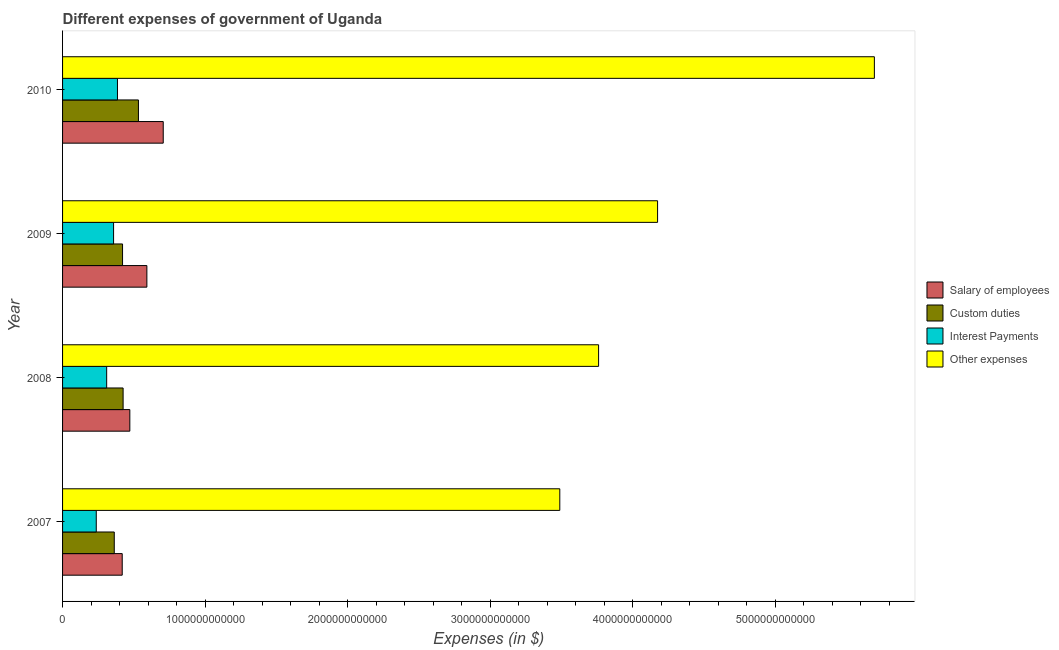How many different coloured bars are there?
Your answer should be very brief. 4. Are the number of bars on each tick of the Y-axis equal?
Your answer should be very brief. Yes. How many bars are there on the 1st tick from the top?
Provide a short and direct response. 4. What is the amount spent on salary of employees in 2010?
Ensure brevity in your answer.  7.06e+11. Across all years, what is the maximum amount spent on custom duties?
Give a very brief answer. 5.32e+11. Across all years, what is the minimum amount spent on interest payments?
Offer a very short reply. 2.36e+11. In which year was the amount spent on other expenses maximum?
Ensure brevity in your answer.  2010. What is the total amount spent on interest payments in the graph?
Ensure brevity in your answer.  1.29e+12. What is the difference between the amount spent on other expenses in 2007 and that in 2010?
Provide a short and direct response. -2.21e+12. What is the difference between the amount spent on custom duties in 2010 and the amount spent on interest payments in 2008?
Your answer should be very brief. 2.23e+11. What is the average amount spent on interest payments per year?
Give a very brief answer. 3.22e+11. In the year 2007, what is the difference between the amount spent on other expenses and amount spent on salary of employees?
Your answer should be compact. 3.07e+12. In how many years, is the amount spent on custom duties greater than 2000000000000 $?
Your answer should be compact. 0. What is the ratio of the amount spent on custom duties in 2007 to that in 2008?
Your answer should be very brief. 0.85. What is the difference between the highest and the second highest amount spent on interest payments?
Your answer should be very brief. 2.73e+1. What is the difference between the highest and the lowest amount spent on custom duties?
Your answer should be very brief. 1.70e+11. What does the 3rd bar from the top in 2010 represents?
Give a very brief answer. Custom duties. What does the 2nd bar from the bottom in 2008 represents?
Your response must be concise. Custom duties. Is it the case that in every year, the sum of the amount spent on salary of employees and amount spent on custom duties is greater than the amount spent on interest payments?
Ensure brevity in your answer.  Yes. How many years are there in the graph?
Your response must be concise. 4. What is the difference between two consecutive major ticks on the X-axis?
Keep it short and to the point. 1.00e+12. Are the values on the major ticks of X-axis written in scientific E-notation?
Provide a short and direct response. No. Does the graph contain any zero values?
Offer a very short reply. No. Does the graph contain grids?
Your answer should be very brief. No. Where does the legend appear in the graph?
Give a very brief answer. Center right. How many legend labels are there?
Offer a terse response. 4. What is the title of the graph?
Keep it short and to the point. Different expenses of government of Uganda. What is the label or title of the X-axis?
Provide a short and direct response. Expenses (in $). What is the Expenses (in $) in Salary of employees in 2007?
Your response must be concise. 4.18e+11. What is the Expenses (in $) of Custom duties in 2007?
Your answer should be compact. 3.63e+11. What is the Expenses (in $) in Interest Payments in 2007?
Provide a short and direct response. 2.36e+11. What is the Expenses (in $) of Other expenses in 2007?
Your response must be concise. 3.49e+12. What is the Expenses (in $) in Salary of employees in 2008?
Give a very brief answer. 4.72e+11. What is the Expenses (in $) of Custom duties in 2008?
Keep it short and to the point. 4.25e+11. What is the Expenses (in $) in Interest Payments in 2008?
Provide a succinct answer. 3.09e+11. What is the Expenses (in $) in Other expenses in 2008?
Provide a succinct answer. 3.76e+12. What is the Expenses (in $) of Salary of employees in 2009?
Provide a succinct answer. 5.91e+11. What is the Expenses (in $) of Custom duties in 2009?
Give a very brief answer. 4.21e+11. What is the Expenses (in $) of Interest Payments in 2009?
Offer a very short reply. 3.58e+11. What is the Expenses (in $) in Other expenses in 2009?
Your answer should be very brief. 4.17e+12. What is the Expenses (in $) in Salary of employees in 2010?
Give a very brief answer. 7.06e+11. What is the Expenses (in $) of Custom duties in 2010?
Ensure brevity in your answer.  5.32e+11. What is the Expenses (in $) in Interest Payments in 2010?
Offer a terse response. 3.85e+11. What is the Expenses (in $) of Other expenses in 2010?
Your answer should be very brief. 5.69e+12. Across all years, what is the maximum Expenses (in $) in Salary of employees?
Your response must be concise. 7.06e+11. Across all years, what is the maximum Expenses (in $) of Custom duties?
Offer a terse response. 5.32e+11. Across all years, what is the maximum Expenses (in $) in Interest Payments?
Your answer should be very brief. 3.85e+11. Across all years, what is the maximum Expenses (in $) in Other expenses?
Your response must be concise. 5.69e+12. Across all years, what is the minimum Expenses (in $) in Salary of employees?
Your answer should be compact. 4.18e+11. Across all years, what is the minimum Expenses (in $) of Custom duties?
Your answer should be very brief. 3.63e+11. Across all years, what is the minimum Expenses (in $) in Interest Payments?
Your response must be concise. 2.36e+11. Across all years, what is the minimum Expenses (in $) of Other expenses?
Your answer should be compact. 3.49e+12. What is the total Expenses (in $) in Salary of employees in the graph?
Your response must be concise. 2.19e+12. What is the total Expenses (in $) of Custom duties in the graph?
Make the answer very short. 1.74e+12. What is the total Expenses (in $) of Interest Payments in the graph?
Your response must be concise. 1.29e+12. What is the total Expenses (in $) in Other expenses in the graph?
Keep it short and to the point. 1.71e+13. What is the difference between the Expenses (in $) of Salary of employees in 2007 and that in 2008?
Your response must be concise. -5.33e+1. What is the difference between the Expenses (in $) in Custom duties in 2007 and that in 2008?
Make the answer very short. -6.20e+1. What is the difference between the Expenses (in $) in Interest Payments in 2007 and that in 2008?
Your answer should be compact. -7.31e+1. What is the difference between the Expenses (in $) in Other expenses in 2007 and that in 2008?
Provide a short and direct response. -2.72e+11. What is the difference between the Expenses (in $) in Salary of employees in 2007 and that in 2009?
Ensure brevity in your answer.  -1.73e+11. What is the difference between the Expenses (in $) of Custom duties in 2007 and that in 2009?
Your answer should be compact. -5.81e+1. What is the difference between the Expenses (in $) in Interest Payments in 2007 and that in 2009?
Give a very brief answer. -1.22e+11. What is the difference between the Expenses (in $) in Other expenses in 2007 and that in 2009?
Your answer should be very brief. -6.86e+11. What is the difference between the Expenses (in $) in Salary of employees in 2007 and that in 2010?
Keep it short and to the point. -2.88e+11. What is the difference between the Expenses (in $) in Custom duties in 2007 and that in 2010?
Give a very brief answer. -1.70e+11. What is the difference between the Expenses (in $) in Interest Payments in 2007 and that in 2010?
Keep it short and to the point. -1.49e+11. What is the difference between the Expenses (in $) in Other expenses in 2007 and that in 2010?
Your answer should be compact. -2.21e+12. What is the difference between the Expenses (in $) of Salary of employees in 2008 and that in 2009?
Keep it short and to the point. -1.20e+11. What is the difference between the Expenses (in $) in Custom duties in 2008 and that in 2009?
Offer a terse response. 3.91e+09. What is the difference between the Expenses (in $) in Interest Payments in 2008 and that in 2009?
Ensure brevity in your answer.  -4.85e+1. What is the difference between the Expenses (in $) in Other expenses in 2008 and that in 2009?
Your answer should be very brief. -4.14e+11. What is the difference between the Expenses (in $) in Salary of employees in 2008 and that in 2010?
Make the answer very short. -2.34e+11. What is the difference between the Expenses (in $) in Custom duties in 2008 and that in 2010?
Provide a succinct answer. -1.08e+11. What is the difference between the Expenses (in $) of Interest Payments in 2008 and that in 2010?
Make the answer very short. -7.57e+1. What is the difference between the Expenses (in $) of Other expenses in 2008 and that in 2010?
Your response must be concise. -1.93e+12. What is the difference between the Expenses (in $) of Salary of employees in 2009 and that in 2010?
Your answer should be very brief. -1.15e+11. What is the difference between the Expenses (in $) of Custom duties in 2009 and that in 2010?
Offer a very short reply. -1.11e+11. What is the difference between the Expenses (in $) in Interest Payments in 2009 and that in 2010?
Provide a short and direct response. -2.73e+1. What is the difference between the Expenses (in $) of Other expenses in 2009 and that in 2010?
Ensure brevity in your answer.  -1.52e+12. What is the difference between the Expenses (in $) in Salary of employees in 2007 and the Expenses (in $) in Custom duties in 2008?
Ensure brevity in your answer.  -6.22e+09. What is the difference between the Expenses (in $) in Salary of employees in 2007 and the Expenses (in $) in Interest Payments in 2008?
Give a very brief answer. 1.09e+11. What is the difference between the Expenses (in $) of Salary of employees in 2007 and the Expenses (in $) of Other expenses in 2008?
Keep it short and to the point. -3.34e+12. What is the difference between the Expenses (in $) of Custom duties in 2007 and the Expenses (in $) of Interest Payments in 2008?
Make the answer very short. 5.33e+1. What is the difference between the Expenses (in $) in Custom duties in 2007 and the Expenses (in $) in Other expenses in 2008?
Your answer should be very brief. -3.40e+12. What is the difference between the Expenses (in $) in Interest Payments in 2007 and the Expenses (in $) in Other expenses in 2008?
Keep it short and to the point. -3.52e+12. What is the difference between the Expenses (in $) in Salary of employees in 2007 and the Expenses (in $) in Custom duties in 2009?
Make the answer very short. -2.30e+09. What is the difference between the Expenses (in $) of Salary of employees in 2007 and the Expenses (in $) of Interest Payments in 2009?
Give a very brief answer. 6.06e+1. What is the difference between the Expenses (in $) in Salary of employees in 2007 and the Expenses (in $) in Other expenses in 2009?
Provide a succinct answer. -3.76e+12. What is the difference between the Expenses (in $) of Custom duties in 2007 and the Expenses (in $) of Interest Payments in 2009?
Offer a terse response. 4.82e+09. What is the difference between the Expenses (in $) in Custom duties in 2007 and the Expenses (in $) in Other expenses in 2009?
Ensure brevity in your answer.  -3.81e+12. What is the difference between the Expenses (in $) in Interest Payments in 2007 and the Expenses (in $) in Other expenses in 2009?
Make the answer very short. -3.94e+12. What is the difference between the Expenses (in $) of Salary of employees in 2007 and the Expenses (in $) of Custom duties in 2010?
Provide a succinct answer. -1.14e+11. What is the difference between the Expenses (in $) of Salary of employees in 2007 and the Expenses (in $) of Interest Payments in 2010?
Your response must be concise. 3.33e+1. What is the difference between the Expenses (in $) of Salary of employees in 2007 and the Expenses (in $) of Other expenses in 2010?
Provide a short and direct response. -5.28e+12. What is the difference between the Expenses (in $) in Custom duties in 2007 and the Expenses (in $) in Interest Payments in 2010?
Ensure brevity in your answer.  -2.24e+1. What is the difference between the Expenses (in $) of Custom duties in 2007 and the Expenses (in $) of Other expenses in 2010?
Keep it short and to the point. -5.33e+12. What is the difference between the Expenses (in $) of Interest Payments in 2007 and the Expenses (in $) of Other expenses in 2010?
Offer a terse response. -5.46e+12. What is the difference between the Expenses (in $) in Salary of employees in 2008 and the Expenses (in $) in Custom duties in 2009?
Your response must be concise. 5.10e+1. What is the difference between the Expenses (in $) of Salary of employees in 2008 and the Expenses (in $) of Interest Payments in 2009?
Your answer should be compact. 1.14e+11. What is the difference between the Expenses (in $) of Salary of employees in 2008 and the Expenses (in $) of Other expenses in 2009?
Provide a succinct answer. -3.70e+12. What is the difference between the Expenses (in $) of Custom duties in 2008 and the Expenses (in $) of Interest Payments in 2009?
Your answer should be compact. 6.68e+1. What is the difference between the Expenses (in $) in Custom duties in 2008 and the Expenses (in $) in Other expenses in 2009?
Your answer should be very brief. -3.75e+12. What is the difference between the Expenses (in $) in Interest Payments in 2008 and the Expenses (in $) in Other expenses in 2009?
Provide a short and direct response. -3.86e+12. What is the difference between the Expenses (in $) of Salary of employees in 2008 and the Expenses (in $) of Custom duties in 2010?
Provide a succinct answer. -6.04e+1. What is the difference between the Expenses (in $) of Salary of employees in 2008 and the Expenses (in $) of Interest Payments in 2010?
Offer a terse response. 8.66e+1. What is the difference between the Expenses (in $) of Salary of employees in 2008 and the Expenses (in $) of Other expenses in 2010?
Your answer should be very brief. -5.22e+12. What is the difference between the Expenses (in $) in Custom duties in 2008 and the Expenses (in $) in Interest Payments in 2010?
Provide a succinct answer. 3.96e+1. What is the difference between the Expenses (in $) of Custom duties in 2008 and the Expenses (in $) of Other expenses in 2010?
Provide a succinct answer. -5.27e+12. What is the difference between the Expenses (in $) in Interest Payments in 2008 and the Expenses (in $) in Other expenses in 2010?
Offer a very short reply. -5.38e+12. What is the difference between the Expenses (in $) of Salary of employees in 2009 and the Expenses (in $) of Custom duties in 2010?
Your answer should be very brief. 5.92e+1. What is the difference between the Expenses (in $) in Salary of employees in 2009 and the Expenses (in $) in Interest Payments in 2010?
Your answer should be compact. 2.06e+11. What is the difference between the Expenses (in $) of Salary of employees in 2009 and the Expenses (in $) of Other expenses in 2010?
Ensure brevity in your answer.  -5.10e+12. What is the difference between the Expenses (in $) in Custom duties in 2009 and the Expenses (in $) in Interest Payments in 2010?
Keep it short and to the point. 3.56e+1. What is the difference between the Expenses (in $) in Custom duties in 2009 and the Expenses (in $) in Other expenses in 2010?
Your answer should be compact. -5.27e+12. What is the difference between the Expenses (in $) of Interest Payments in 2009 and the Expenses (in $) of Other expenses in 2010?
Offer a very short reply. -5.34e+12. What is the average Expenses (in $) in Salary of employees per year?
Your response must be concise. 5.47e+11. What is the average Expenses (in $) in Custom duties per year?
Offer a terse response. 4.35e+11. What is the average Expenses (in $) of Interest Payments per year?
Give a very brief answer. 3.22e+11. What is the average Expenses (in $) of Other expenses per year?
Ensure brevity in your answer.  4.28e+12. In the year 2007, what is the difference between the Expenses (in $) of Salary of employees and Expenses (in $) of Custom duties?
Provide a succinct answer. 5.58e+1. In the year 2007, what is the difference between the Expenses (in $) in Salary of employees and Expenses (in $) in Interest Payments?
Your response must be concise. 1.82e+11. In the year 2007, what is the difference between the Expenses (in $) in Salary of employees and Expenses (in $) in Other expenses?
Your answer should be compact. -3.07e+12. In the year 2007, what is the difference between the Expenses (in $) in Custom duties and Expenses (in $) in Interest Payments?
Your answer should be compact. 1.26e+11. In the year 2007, what is the difference between the Expenses (in $) in Custom duties and Expenses (in $) in Other expenses?
Ensure brevity in your answer.  -3.13e+12. In the year 2007, what is the difference between the Expenses (in $) of Interest Payments and Expenses (in $) of Other expenses?
Give a very brief answer. -3.25e+12. In the year 2008, what is the difference between the Expenses (in $) in Salary of employees and Expenses (in $) in Custom duties?
Your answer should be compact. 4.71e+1. In the year 2008, what is the difference between the Expenses (in $) in Salary of employees and Expenses (in $) in Interest Payments?
Your answer should be very brief. 1.62e+11. In the year 2008, what is the difference between the Expenses (in $) of Salary of employees and Expenses (in $) of Other expenses?
Make the answer very short. -3.29e+12. In the year 2008, what is the difference between the Expenses (in $) of Custom duties and Expenses (in $) of Interest Payments?
Provide a short and direct response. 1.15e+11. In the year 2008, what is the difference between the Expenses (in $) of Custom duties and Expenses (in $) of Other expenses?
Your response must be concise. -3.34e+12. In the year 2008, what is the difference between the Expenses (in $) in Interest Payments and Expenses (in $) in Other expenses?
Ensure brevity in your answer.  -3.45e+12. In the year 2009, what is the difference between the Expenses (in $) of Salary of employees and Expenses (in $) of Custom duties?
Provide a short and direct response. 1.71e+11. In the year 2009, what is the difference between the Expenses (in $) in Salary of employees and Expenses (in $) in Interest Payments?
Your response must be concise. 2.33e+11. In the year 2009, what is the difference between the Expenses (in $) of Salary of employees and Expenses (in $) of Other expenses?
Your answer should be very brief. -3.58e+12. In the year 2009, what is the difference between the Expenses (in $) of Custom duties and Expenses (in $) of Interest Payments?
Provide a short and direct response. 6.29e+1. In the year 2009, what is the difference between the Expenses (in $) of Custom duties and Expenses (in $) of Other expenses?
Offer a terse response. -3.75e+12. In the year 2009, what is the difference between the Expenses (in $) in Interest Payments and Expenses (in $) in Other expenses?
Provide a short and direct response. -3.82e+12. In the year 2010, what is the difference between the Expenses (in $) of Salary of employees and Expenses (in $) of Custom duties?
Your answer should be compact. 1.74e+11. In the year 2010, what is the difference between the Expenses (in $) of Salary of employees and Expenses (in $) of Interest Payments?
Ensure brevity in your answer.  3.21e+11. In the year 2010, what is the difference between the Expenses (in $) of Salary of employees and Expenses (in $) of Other expenses?
Your answer should be compact. -4.99e+12. In the year 2010, what is the difference between the Expenses (in $) in Custom duties and Expenses (in $) in Interest Payments?
Keep it short and to the point. 1.47e+11. In the year 2010, what is the difference between the Expenses (in $) of Custom duties and Expenses (in $) of Other expenses?
Your response must be concise. -5.16e+12. In the year 2010, what is the difference between the Expenses (in $) in Interest Payments and Expenses (in $) in Other expenses?
Keep it short and to the point. -5.31e+12. What is the ratio of the Expenses (in $) in Salary of employees in 2007 to that in 2008?
Offer a very short reply. 0.89. What is the ratio of the Expenses (in $) of Custom duties in 2007 to that in 2008?
Your answer should be very brief. 0.85. What is the ratio of the Expenses (in $) of Interest Payments in 2007 to that in 2008?
Provide a succinct answer. 0.76. What is the ratio of the Expenses (in $) in Other expenses in 2007 to that in 2008?
Your answer should be very brief. 0.93. What is the ratio of the Expenses (in $) in Salary of employees in 2007 to that in 2009?
Your answer should be compact. 0.71. What is the ratio of the Expenses (in $) in Custom duties in 2007 to that in 2009?
Your answer should be very brief. 0.86. What is the ratio of the Expenses (in $) of Interest Payments in 2007 to that in 2009?
Provide a short and direct response. 0.66. What is the ratio of the Expenses (in $) of Other expenses in 2007 to that in 2009?
Offer a terse response. 0.84. What is the ratio of the Expenses (in $) in Salary of employees in 2007 to that in 2010?
Give a very brief answer. 0.59. What is the ratio of the Expenses (in $) in Custom duties in 2007 to that in 2010?
Your answer should be compact. 0.68. What is the ratio of the Expenses (in $) in Interest Payments in 2007 to that in 2010?
Your response must be concise. 0.61. What is the ratio of the Expenses (in $) of Other expenses in 2007 to that in 2010?
Offer a terse response. 0.61. What is the ratio of the Expenses (in $) of Salary of employees in 2008 to that in 2009?
Ensure brevity in your answer.  0.8. What is the ratio of the Expenses (in $) of Custom duties in 2008 to that in 2009?
Ensure brevity in your answer.  1.01. What is the ratio of the Expenses (in $) in Interest Payments in 2008 to that in 2009?
Your response must be concise. 0.86. What is the ratio of the Expenses (in $) in Other expenses in 2008 to that in 2009?
Provide a succinct answer. 0.9. What is the ratio of the Expenses (in $) of Salary of employees in 2008 to that in 2010?
Your answer should be very brief. 0.67. What is the ratio of the Expenses (in $) of Custom duties in 2008 to that in 2010?
Your response must be concise. 0.8. What is the ratio of the Expenses (in $) of Interest Payments in 2008 to that in 2010?
Offer a terse response. 0.8. What is the ratio of the Expenses (in $) in Other expenses in 2008 to that in 2010?
Your answer should be compact. 0.66. What is the ratio of the Expenses (in $) in Salary of employees in 2009 to that in 2010?
Offer a terse response. 0.84. What is the ratio of the Expenses (in $) in Custom duties in 2009 to that in 2010?
Make the answer very short. 0.79. What is the ratio of the Expenses (in $) of Interest Payments in 2009 to that in 2010?
Give a very brief answer. 0.93. What is the ratio of the Expenses (in $) in Other expenses in 2009 to that in 2010?
Ensure brevity in your answer.  0.73. What is the difference between the highest and the second highest Expenses (in $) of Salary of employees?
Make the answer very short. 1.15e+11. What is the difference between the highest and the second highest Expenses (in $) in Custom duties?
Ensure brevity in your answer.  1.08e+11. What is the difference between the highest and the second highest Expenses (in $) in Interest Payments?
Provide a succinct answer. 2.73e+1. What is the difference between the highest and the second highest Expenses (in $) in Other expenses?
Your answer should be compact. 1.52e+12. What is the difference between the highest and the lowest Expenses (in $) in Salary of employees?
Offer a very short reply. 2.88e+11. What is the difference between the highest and the lowest Expenses (in $) in Custom duties?
Offer a very short reply. 1.70e+11. What is the difference between the highest and the lowest Expenses (in $) in Interest Payments?
Ensure brevity in your answer.  1.49e+11. What is the difference between the highest and the lowest Expenses (in $) of Other expenses?
Your answer should be compact. 2.21e+12. 